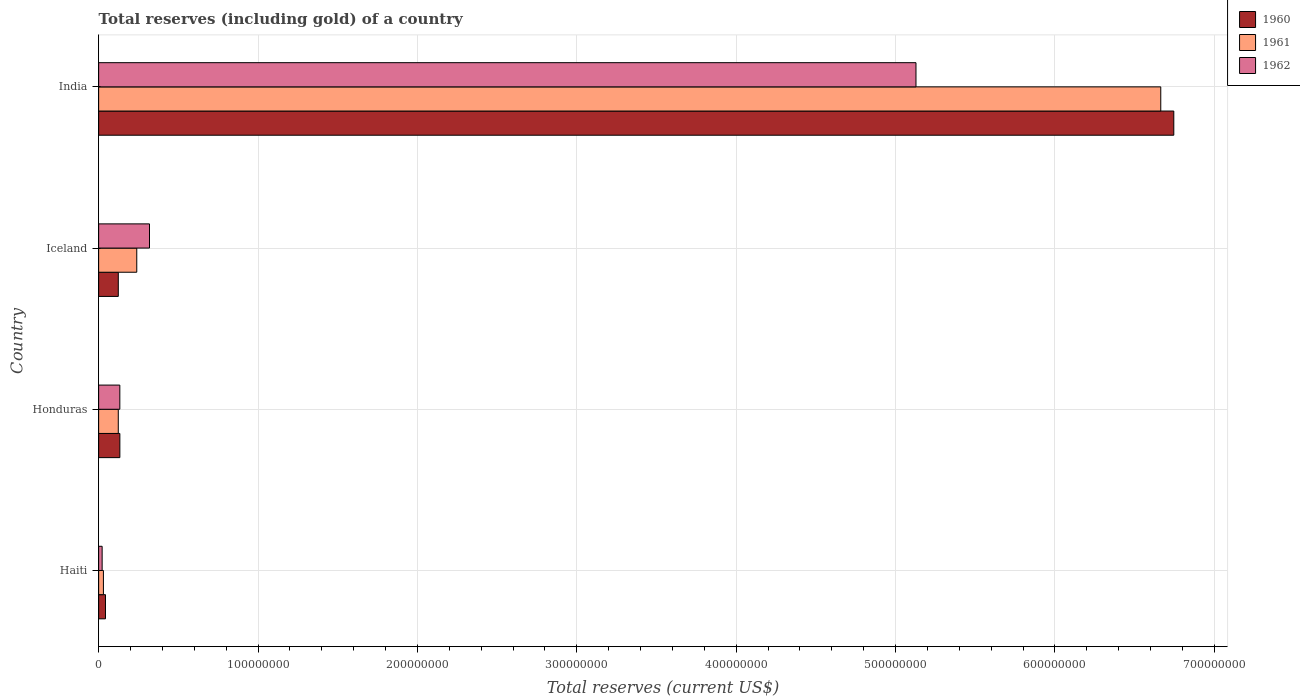How many different coloured bars are there?
Offer a terse response. 3. How many groups of bars are there?
Your response must be concise. 4. Are the number of bars per tick equal to the number of legend labels?
Offer a very short reply. Yes. Are the number of bars on each tick of the Y-axis equal?
Offer a very short reply. Yes. How many bars are there on the 2nd tick from the top?
Ensure brevity in your answer.  3. What is the label of the 4th group of bars from the top?
Offer a terse response. Haiti. What is the total reserves (including gold) in 1962 in Iceland?
Your response must be concise. 3.19e+07. Across all countries, what is the maximum total reserves (including gold) in 1962?
Your response must be concise. 5.13e+08. Across all countries, what is the minimum total reserves (including gold) in 1962?
Provide a short and direct response. 2.20e+06. In which country was the total reserves (including gold) in 1960 maximum?
Ensure brevity in your answer.  India. In which country was the total reserves (including gold) in 1961 minimum?
Keep it short and to the point. Haiti. What is the total total reserves (including gold) in 1961 in the graph?
Make the answer very short. 7.06e+08. What is the difference between the total reserves (including gold) in 1961 in Iceland and that in India?
Give a very brief answer. -6.42e+08. What is the difference between the total reserves (including gold) in 1961 in India and the total reserves (including gold) in 1960 in Honduras?
Your answer should be compact. 6.53e+08. What is the average total reserves (including gold) in 1962 per country?
Your response must be concise. 1.40e+08. What is the difference between the total reserves (including gold) in 1962 and total reserves (including gold) in 1960 in India?
Give a very brief answer. -1.62e+08. What is the ratio of the total reserves (including gold) in 1962 in Iceland to that in India?
Give a very brief answer. 0.06. What is the difference between the highest and the second highest total reserves (including gold) in 1961?
Your answer should be very brief. 6.42e+08. What is the difference between the highest and the lowest total reserves (including gold) in 1960?
Your answer should be compact. 6.70e+08. What does the 3rd bar from the top in Haiti represents?
Offer a very short reply. 1960. Is it the case that in every country, the sum of the total reserves (including gold) in 1960 and total reserves (including gold) in 1961 is greater than the total reserves (including gold) in 1962?
Your answer should be very brief. Yes. How many bars are there?
Give a very brief answer. 12. How many countries are there in the graph?
Keep it short and to the point. 4. Are the values on the major ticks of X-axis written in scientific E-notation?
Your answer should be compact. No. Does the graph contain any zero values?
Your answer should be compact. No. Where does the legend appear in the graph?
Make the answer very short. Top right. How many legend labels are there?
Provide a short and direct response. 3. How are the legend labels stacked?
Keep it short and to the point. Vertical. What is the title of the graph?
Ensure brevity in your answer.  Total reserves (including gold) of a country. What is the label or title of the X-axis?
Keep it short and to the point. Total reserves (current US$). What is the Total reserves (current US$) of 1960 in Haiti?
Your answer should be very brief. 4.30e+06. What is the Total reserves (current US$) in 1962 in Haiti?
Provide a short and direct response. 2.20e+06. What is the Total reserves (current US$) in 1960 in Honduras?
Give a very brief answer. 1.33e+07. What is the Total reserves (current US$) in 1961 in Honduras?
Offer a very short reply. 1.23e+07. What is the Total reserves (current US$) in 1962 in Honduras?
Provide a succinct answer. 1.33e+07. What is the Total reserves (current US$) of 1960 in Iceland?
Offer a terse response. 1.23e+07. What is the Total reserves (current US$) in 1961 in Iceland?
Offer a very short reply. 2.39e+07. What is the Total reserves (current US$) in 1962 in Iceland?
Your answer should be very brief. 3.19e+07. What is the Total reserves (current US$) in 1960 in India?
Your answer should be compact. 6.75e+08. What is the Total reserves (current US$) in 1961 in India?
Provide a succinct answer. 6.66e+08. What is the Total reserves (current US$) in 1962 in India?
Offer a very short reply. 5.13e+08. Across all countries, what is the maximum Total reserves (current US$) of 1960?
Make the answer very short. 6.75e+08. Across all countries, what is the maximum Total reserves (current US$) of 1961?
Your answer should be very brief. 6.66e+08. Across all countries, what is the maximum Total reserves (current US$) of 1962?
Offer a very short reply. 5.13e+08. Across all countries, what is the minimum Total reserves (current US$) in 1960?
Your answer should be compact. 4.30e+06. Across all countries, what is the minimum Total reserves (current US$) in 1962?
Give a very brief answer. 2.20e+06. What is the total Total reserves (current US$) of 1960 in the graph?
Keep it short and to the point. 7.04e+08. What is the total Total reserves (current US$) in 1961 in the graph?
Provide a short and direct response. 7.06e+08. What is the total Total reserves (current US$) in 1962 in the graph?
Offer a terse response. 5.60e+08. What is the difference between the Total reserves (current US$) in 1960 in Haiti and that in Honduras?
Your answer should be very brief. -9.02e+06. What is the difference between the Total reserves (current US$) of 1961 in Haiti and that in Honduras?
Make the answer very short. -9.33e+06. What is the difference between the Total reserves (current US$) in 1962 in Haiti and that in Honduras?
Your response must be concise. -1.11e+07. What is the difference between the Total reserves (current US$) of 1960 in Haiti and that in Iceland?
Offer a very short reply. -8.03e+06. What is the difference between the Total reserves (current US$) in 1961 in Haiti and that in Iceland?
Your answer should be very brief. -2.09e+07. What is the difference between the Total reserves (current US$) of 1962 in Haiti and that in Iceland?
Offer a very short reply. -2.97e+07. What is the difference between the Total reserves (current US$) of 1960 in Haiti and that in India?
Offer a very short reply. -6.70e+08. What is the difference between the Total reserves (current US$) of 1961 in Haiti and that in India?
Provide a succinct answer. -6.63e+08. What is the difference between the Total reserves (current US$) of 1962 in Haiti and that in India?
Make the answer very short. -5.11e+08. What is the difference between the Total reserves (current US$) in 1960 in Honduras and that in Iceland?
Make the answer very short. 9.88e+05. What is the difference between the Total reserves (current US$) of 1961 in Honduras and that in Iceland?
Keep it short and to the point. -1.16e+07. What is the difference between the Total reserves (current US$) of 1962 in Honduras and that in Iceland?
Keep it short and to the point. -1.86e+07. What is the difference between the Total reserves (current US$) of 1960 in Honduras and that in India?
Your answer should be compact. -6.61e+08. What is the difference between the Total reserves (current US$) in 1961 in Honduras and that in India?
Ensure brevity in your answer.  -6.54e+08. What is the difference between the Total reserves (current US$) of 1962 in Honduras and that in India?
Your response must be concise. -4.99e+08. What is the difference between the Total reserves (current US$) of 1960 in Iceland and that in India?
Offer a terse response. -6.62e+08. What is the difference between the Total reserves (current US$) of 1961 in Iceland and that in India?
Provide a short and direct response. -6.42e+08. What is the difference between the Total reserves (current US$) in 1962 in Iceland and that in India?
Your answer should be very brief. -4.81e+08. What is the difference between the Total reserves (current US$) of 1960 in Haiti and the Total reserves (current US$) of 1961 in Honduras?
Offer a very short reply. -8.03e+06. What is the difference between the Total reserves (current US$) of 1960 in Haiti and the Total reserves (current US$) of 1962 in Honduras?
Ensure brevity in your answer.  -9.00e+06. What is the difference between the Total reserves (current US$) in 1961 in Haiti and the Total reserves (current US$) in 1962 in Honduras?
Provide a succinct answer. -1.03e+07. What is the difference between the Total reserves (current US$) of 1960 in Haiti and the Total reserves (current US$) of 1961 in Iceland?
Your answer should be very brief. -1.96e+07. What is the difference between the Total reserves (current US$) of 1960 in Haiti and the Total reserves (current US$) of 1962 in Iceland?
Offer a terse response. -2.76e+07. What is the difference between the Total reserves (current US$) of 1961 in Haiti and the Total reserves (current US$) of 1962 in Iceland?
Give a very brief answer. -2.89e+07. What is the difference between the Total reserves (current US$) of 1960 in Haiti and the Total reserves (current US$) of 1961 in India?
Make the answer very short. -6.62e+08. What is the difference between the Total reserves (current US$) in 1960 in Haiti and the Total reserves (current US$) in 1962 in India?
Your answer should be compact. -5.08e+08. What is the difference between the Total reserves (current US$) of 1961 in Haiti and the Total reserves (current US$) of 1962 in India?
Give a very brief answer. -5.10e+08. What is the difference between the Total reserves (current US$) of 1960 in Honduras and the Total reserves (current US$) of 1961 in Iceland?
Make the answer very short. -1.06e+07. What is the difference between the Total reserves (current US$) in 1960 in Honduras and the Total reserves (current US$) in 1962 in Iceland?
Offer a terse response. -1.86e+07. What is the difference between the Total reserves (current US$) of 1961 in Honduras and the Total reserves (current US$) of 1962 in Iceland?
Offer a very short reply. -1.96e+07. What is the difference between the Total reserves (current US$) of 1960 in Honduras and the Total reserves (current US$) of 1961 in India?
Your answer should be very brief. -6.53e+08. What is the difference between the Total reserves (current US$) in 1960 in Honduras and the Total reserves (current US$) in 1962 in India?
Provide a short and direct response. -4.99e+08. What is the difference between the Total reserves (current US$) in 1961 in Honduras and the Total reserves (current US$) in 1962 in India?
Offer a terse response. -5.00e+08. What is the difference between the Total reserves (current US$) in 1960 in Iceland and the Total reserves (current US$) in 1961 in India?
Give a very brief answer. -6.54e+08. What is the difference between the Total reserves (current US$) in 1960 in Iceland and the Total reserves (current US$) in 1962 in India?
Provide a succinct answer. -5.00e+08. What is the difference between the Total reserves (current US$) in 1961 in Iceland and the Total reserves (current US$) in 1962 in India?
Provide a succinct answer. -4.89e+08. What is the average Total reserves (current US$) of 1960 per country?
Keep it short and to the point. 1.76e+08. What is the average Total reserves (current US$) of 1961 per country?
Your answer should be very brief. 1.76e+08. What is the average Total reserves (current US$) of 1962 per country?
Keep it short and to the point. 1.40e+08. What is the difference between the Total reserves (current US$) in 1960 and Total reserves (current US$) in 1961 in Haiti?
Your answer should be compact. 1.30e+06. What is the difference between the Total reserves (current US$) of 1960 and Total reserves (current US$) of 1962 in Haiti?
Make the answer very short. 2.10e+06. What is the difference between the Total reserves (current US$) of 1960 and Total reserves (current US$) of 1961 in Honduras?
Provide a succinct answer. 9.91e+05. What is the difference between the Total reserves (current US$) of 1960 and Total reserves (current US$) of 1962 in Honduras?
Your answer should be very brief. 2.16e+04. What is the difference between the Total reserves (current US$) of 1961 and Total reserves (current US$) of 1962 in Honduras?
Your answer should be very brief. -9.70e+05. What is the difference between the Total reserves (current US$) in 1960 and Total reserves (current US$) in 1961 in Iceland?
Your answer should be very brief. -1.16e+07. What is the difference between the Total reserves (current US$) of 1960 and Total reserves (current US$) of 1962 in Iceland?
Ensure brevity in your answer.  -1.96e+07. What is the difference between the Total reserves (current US$) of 1961 and Total reserves (current US$) of 1962 in Iceland?
Your answer should be very brief. -8.00e+06. What is the difference between the Total reserves (current US$) of 1960 and Total reserves (current US$) of 1961 in India?
Make the answer very short. 8.18e+06. What is the difference between the Total reserves (current US$) in 1960 and Total reserves (current US$) in 1962 in India?
Your answer should be very brief. 1.62e+08. What is the difference between the Total reserves (current US$) of 1961 and Total reserves (current US$) of 1962 in India?
Make the answer very short. 1.54e+08. What is the ratio of the Total reserves (current US$) of 1960 in Haiti to that in Honduras?
Make the answer very short. 0.32. What is the ratio of the Total reserves (current US$) of 1961 in Haiti to that in Honduras?
Keep it short and to the point. 0.24. What is the ratio of the Total reserves (current US$) of 1962 in Haiti to that in Honduras?
Provide a short and direct response. 0.17. What is the ratio of the Total reserves (current US$) of 1960 in Haiti to that in Iceland?
Give a very brief answer. 0.35. What is the ratio of the Total reserves (current US$) in 1961 in Haiti to that in Iceland?
Give a very brief answer. 0.13. What is the ratio of the Total reserves (current US$) of 1962 in Haiti to that in Iceland?
Your response must be concise. 0.07. What is the ratio of the Total reserves (current US$) of 1960 in Haiti to that in India?
Ensure brevity in your answer.  0.01. What is the ratio of the Total reserves (current US$) of 1961 in Haiti to that in India?
Your response must be concise. 0. What is the ratio of the Total reserves (current US$) in 1962 in Haiti to that in India?
Offer a very short reply. 0. What is the ratio of the Total reserves (current US$) of 1960 in Honduras to that in Iceland?
Provide a short and direct response. 1.08. What is the ratio of the Total reserves (current US$) of 1961 in Honduras to that in Iceland?
Provide a succinct answer. 0.52. What is the ratio of the Total reserves (current US$) in 1962 in Honduras to that in Iceland?
Provide a short and direct response. 0.42. What is the ratio of the Total reserves (current US$) of 1960 in Honduras to that in India?
Your response must be concise. 0.02. What is the ratio of the Total reserves (current US$) in 1961 in Honduras to that in India?
Ensure brevity in your answer.  0.02. What is the ratio of the Total reserves (current US$) of 1962 in Honduras to that in India?
Make the answer very short. 0.03. What is the ratio of the Total reserves (current US$) in 1960 in Iceland to that in India?
Your answer should be compact. 0.02. What is the ratio of the Total reserves (current US$) of 1961 in Iceland to that in India?
Offer a terse response. 0.04. What is the ratio of the Total reserves (current US$) of 1962 in Iceland to that in India?
Keep it short and to the point. 0.06. What is the difference between the highest and the second highest Total reserves (current US$) of 1960?
Your response must be concise. 6.61e+08. What is the difference between the highest and the second highest Total reserves (current US$) in 1961?
Your answer should be very brief. 6.42e+08. What is the difference between the highest and the second highest Total reserves (current US$) in 1962?
Your answer should be very brief. 4.81e+08. What is the difference between the highest and the lowest Total reserves (current US$) of 1960?
Your answer should be compact. 6.70e+08. What is the difference between the highest and the lowest Total reserves (current US$) in 1961?
Your response must be concise. 6.63e+08. What is the difference between the highest and the lowest Total reserves (current US$) of 1962?
Make the answer very short. 5.11e+08. 